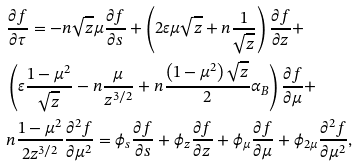<formula> <loc_0><loc_0><loc_500><loc_500>& \frac { \partial f } { \partial \tau } = - n \sqrt { z } \mu \frac { \partial f } { \partial s } + \left ( 2 \varepsilon \mu \sqrt { z } + n \frac { 1 } { \sqrt { z } } \right ) \frac { \partial f } { \partial z } + \\ & \left ( \varepsilon \frac { 1 - \mu ^ { 2 } } { \sqrt { z } } - n \frac { \mu } { z ^ { 3 / 2 } } + n \frac { \left ( 1 - \mu ^ { 2 } \right ) \sqrt { z } } { 2 } \alpha _ { B } \right ) \frac { \partial f } { \partial \mu } + \\ & n \frac { 1 - \mu ^ { 2 } } { 2 z ^ { 3 / 2 } } \frac { \partial ^ { 2 } f } { \partial \mu ^ { 2 } } = \phi _ { s } \frac { \partial f } { \partial s } + \phi _ { z } \frac { \partial f } { \partial z } + \phi _ { \mu } \frac { \partial f } { \partial \mu } + \phi _ { 2 \mu } \frac { \partial ^ { 2 } f } { \partial \mu ^ { 2 } } ,</formula> 